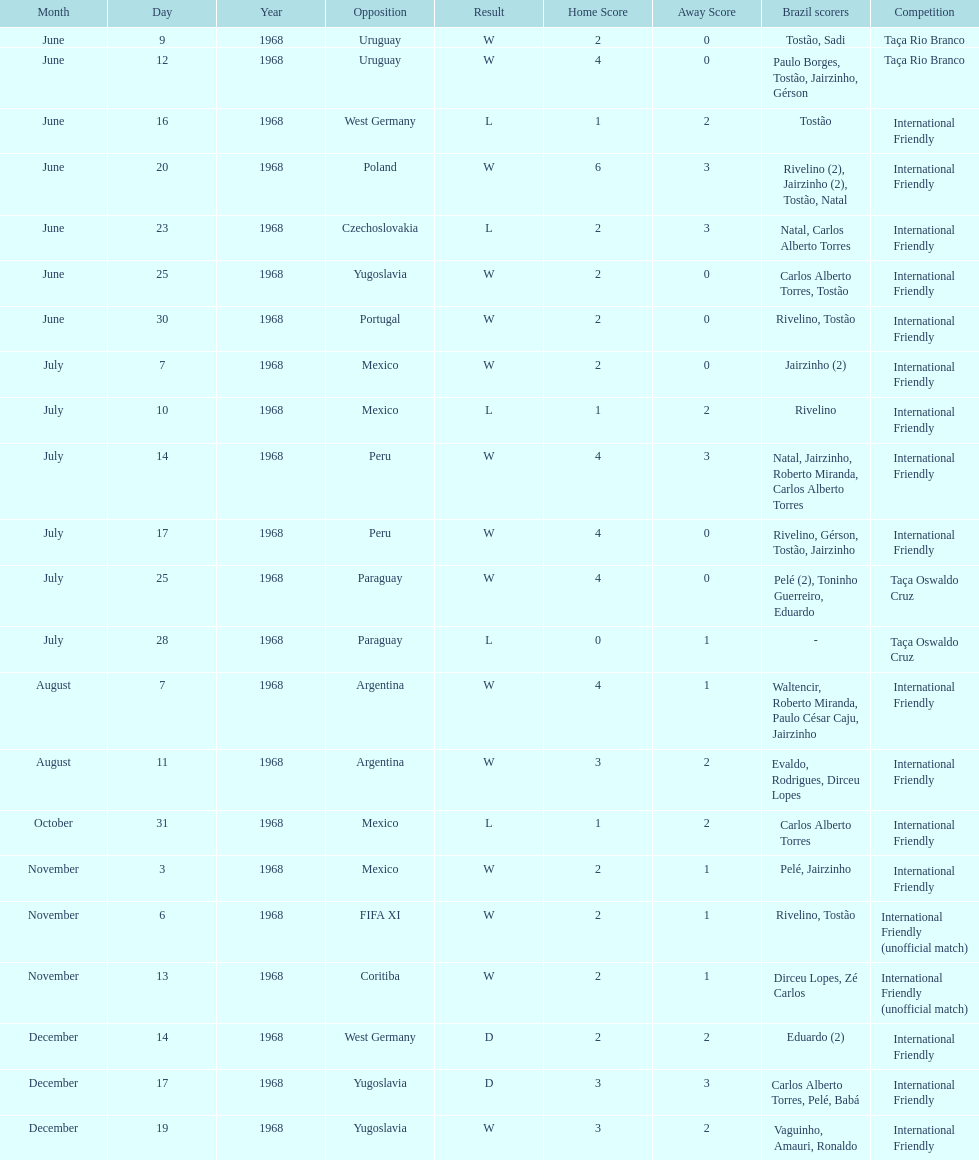How many times did brazil play against argentina in the international friendly competition? 2. Could you parse the entire table as a dict? {'header': ['Month', 'Day', 'Year', 'Opposition', 'Result', 'Home Score', 'Away Score', 'Brazil scorers', 'Competition'], 'rows': [['June', '9', '1968', 'Uruguay', 'W', '2', '0', 'Tostão, Sadi', 'Taça Rio Branco'], ['June', '12', '1968', 'Uruguay', 'W', '4', '0', 'Paulo Borges, Tostão, Jairzinho, Gérson', 'Taça Rio Branco'], ['June', '16', '1968', 'West Germany', 'L', '1', '2', 'Tostão', 'International Friendly'], ['June', '20', '1968', 'Poland', 'W', '6', '3', 'Rivelino (2), Jairzinho (2), Tostão, Natal', 'International Friendly'], ['June', '23', '1968', 'Czechoslovakia', 'L', '2', '3', 'Natal, Carlos Alberto Torres', 'International Friendly'], ['June', '25', '1968', 'Yugoslavia', 'W', '2', '0', 'Carlos Alberto Torres, Tostão', 'International Friendly'], ['June', '30', '1968', 'Portugal', 'W', '2', '0', 'Rivelino, Tostão', 'International Friendly'], ['July', '7', '1968', 'Mexico', 'W', '2', '0', 'Jairzinho (2)', 'International Friendly'], ['July', '10', '1968', 'Mexico', 'L', '1', '2', 'Rivelino', 'International Friendly'], ['July', '14', '1968', 'Peru', 'W', '4', '3', 'Natal, Jairzinho, Roberto Miranda, Carlos Alberto Torres', 'International Friendly'], ['July', '17', '1968', 'Peru', 'W', '4', '0', 'Rivelino, Gérson, Tostão, Jairzinho', 'International Friendly'], ['July', '25', '1968', 'Paraguay', 'W', '4', '0', 'Pelé (2), Toninho Guerreiro, Eduardo', 'Taça Oswaldo Cruz'], ['July', '28', '1968', 'Paraguay', 'L', '0', '1', '-', 'Taça Oswaldo Cruz'], ['August', '7', '1968', 'Argentina', 'W', '4', '1', 'Waltencir, Roberto Miranda, Paulo César Caju, Jairzinho', 'International Friendly'], ['August', '11', '1968', 'Argentina', 'W', '3', '2', 'Evaldo, Rodrigues, Dirceu Lopes', 'International Friendly'], ['October', '31', '1968', 'Mexico', 'L', '1', '2', 'Carlos Alberto Torres', 'International Friendly'], ['November', '3', '1968', 'Mexico', 'W', '2', '1', 'Pelé, Jairzinho', 'International Friendly'], ['November', '6', '1968', 'FIFA XI', 'W', '2', '1', 'Rivelino, Tostão', 'International Friendly (unofficial match)'], ['November', '13', '1968', 'Coritiba', 'W', '2', '1', 'Dirceu Lopes, Zé Carlos', 'International Friendly (unofficial match)'], ['December', '14', '1968', 'West Germany', 'D', '2', '2', 'Eduardo (2)', 'International Friendly'], ['December', '17', '1968', 'Yugoslavia', 'D', '3', '3', 'Carlos Alberto Torres, Pelé, Babá', 'International Friendly'], ['December', '19', '1968', 'Yugoslavia', 'W', '3', '2', 'Vaguinho, Amauri, Ronaldo', 'International Friendly']]} 